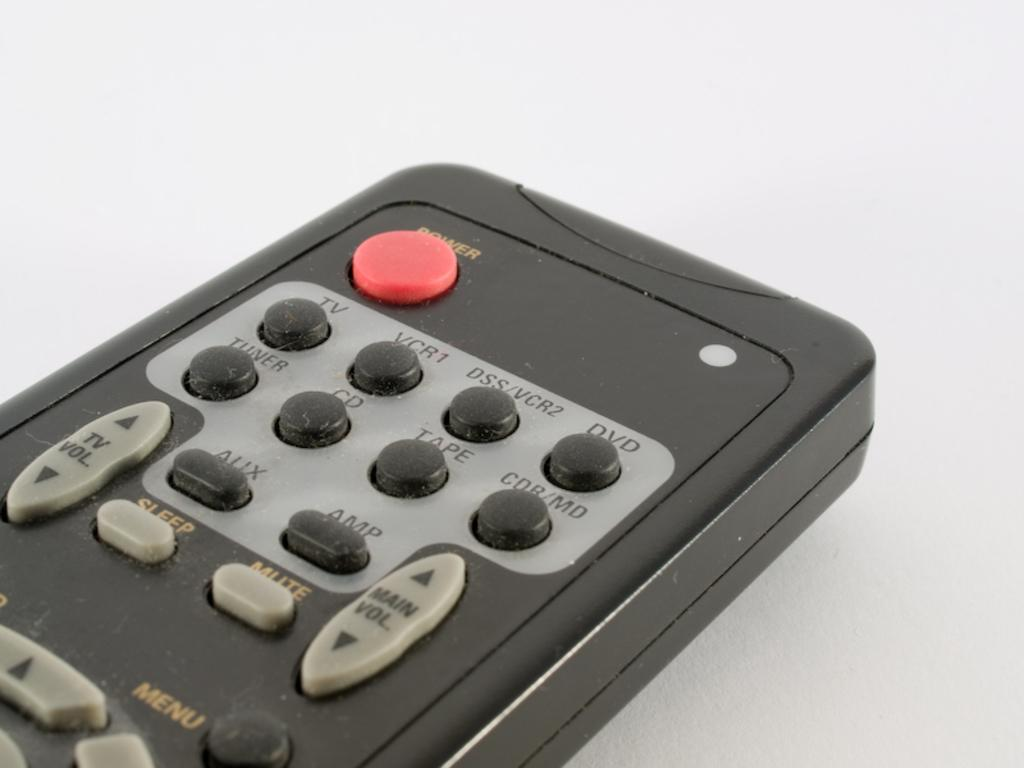<image>
Relay a brief, clear account of the picture shown. Black and gray television remote control with a red power button on the top. 